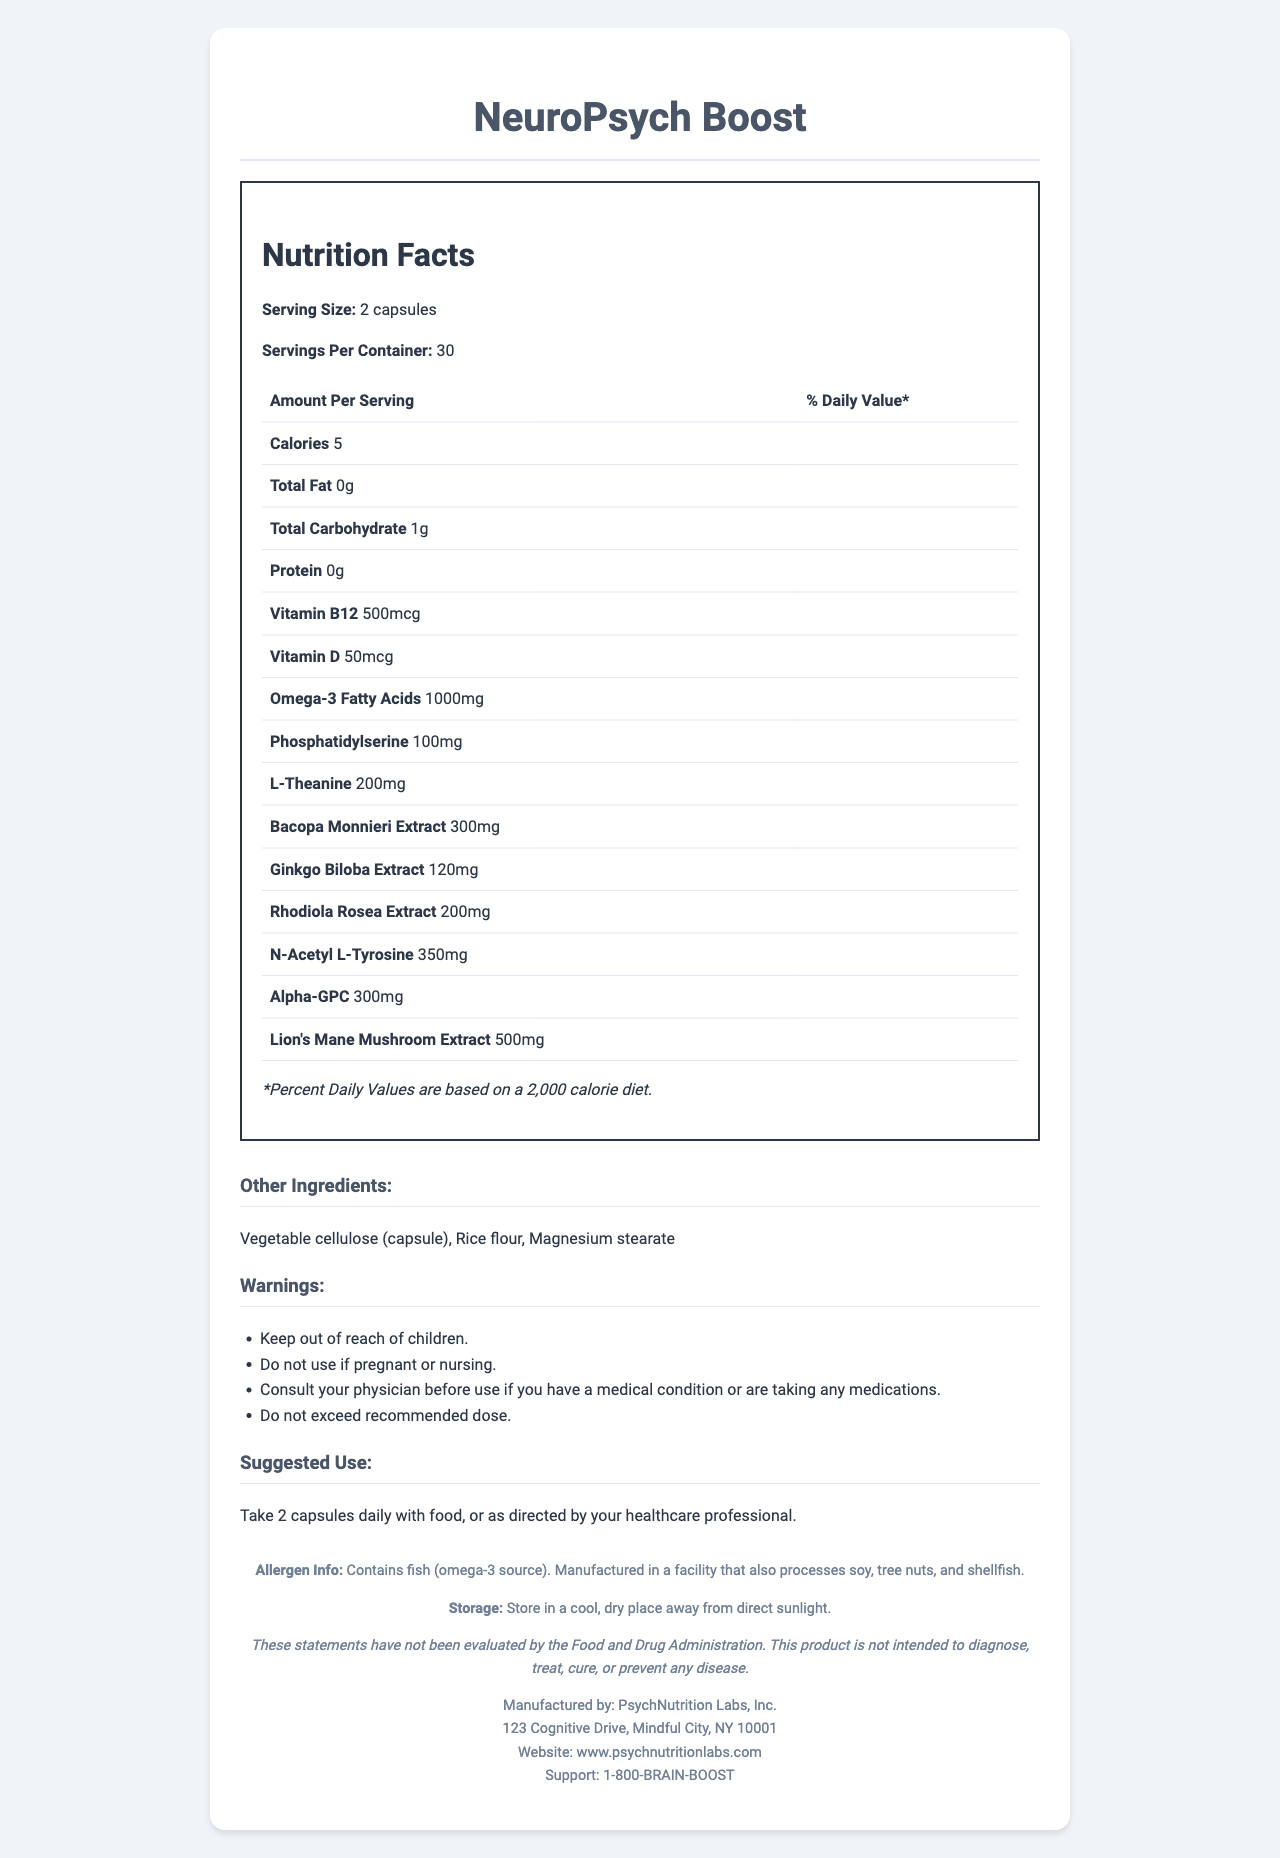what is the serving size? The serving size is mentioned at the beginning of the Nutrition Facts section: "Serving Size: 2 capsules".
Answer: 2 capsules how many servings are there per container? The number of servings per container is listed alongside the serving size in the Nutrition Facts section: "Servings Per Container: 30".
Answer: 30 what is the amount of calories per serving? The amount of calories per serving is shown under the Nutrition Facts: "Calories 5".
Answer: 5 which ingredient has the highest amount per serving? A. Bacopa Monnieri Extract B. Lion's Mane Mushroom Extract C. N-Acetyl L-Tyrosine Lion's Mane Mushroom Extract has 500mg per serving, which is the highest amount per serving compared to the other listed ingredients.
Answer: B does the supplement contain any allergens? The allergen information states: "Contains fish (omega-3 source). Manufactured in a facility that also processes soy, tree nuts, and shellfish."
Answer: Yes what is the suggested use for this supplement? The suggested use is clearly stated under the "Suggested Use" section: "Take 2 capsules daily with food, or as directed by your healthcare professional."
Answer: Take 2 capsules daily with food, or as directed by your healthcare professional. are there any warnings associated with this supplement? The document includes a section titled "Warnings" that lists multiple warnings such as "Keep out of reach of children" and "Do not use if pregnant or nursing."
Answer: Yes who manufactures this product? The manufacturer is listed at the bottom of the document: "Manufactured by: PsychNutrition Labs, Inc."
Answer: PsychNutrition Labs, Inc. what is the source of omega-3 in this supplement? The allergen info reveals: "Contains fish (omega-3 source)." This indicates that fish is the source of omega-3 in the supplement.
Answer: Fish how should the supplement be stored? The storage instructions are given under the storage section: "Store in a cool, dry place away from direct sunlight."
Answer: Store in a cool, dry place away from direct sunlight. can the supplement be used to diagnose, treat, cure, or prevent any disease? The disclaimer states: "These statements have not been evaluated by the Food and Drug Administration. This product is not intended to diagnose, treat, cure, or prevent any disease."
Answer: No are any carbohydrates present in the supplement? If so, how much? The total carbohydrates per serving are listed in the Nutrition Facts section as "Total Carbohydrate: 1g".
Answer: Yes, 1g what is the role of Vitamin B12 in this supplement? The function of Vitamin B12 is not explained in the document. It only states the amount per serving.
Answer: Not enough information summarize the main idea of the document. The document contains comprehensive information about the "NeuroPsych Boost" supplement, including its nutritional content, ingredients, special instructions, and warnings, aimed at guiding users for safe and effective use.
Answer: The document provides a detailed Nutrition Facts Label for "NeuroPsych Boost," a brain-boosting supplement designed to enhance cognitive function. It lists serving size, nutritional content, key ingredients, suggested use, warnings, and manufacturer information. what is the address of the manufacturer? The address of the manufacturer is provided at the bottom of the document: "123 Cognitive Drive, Mindful City, NY 10001".
Answer: 123 Cognitive Drive, Mindful City, NY 10001 which of these ingredients is not included in the supplement? A. L-Theanine B. Bacopa Monnieri Extract C. Melatonin The listed ingredients include L-Theanine and Bacopa Monnieri Extract, but there is no mention of Melatonin among the ingredients.
Answer: C 